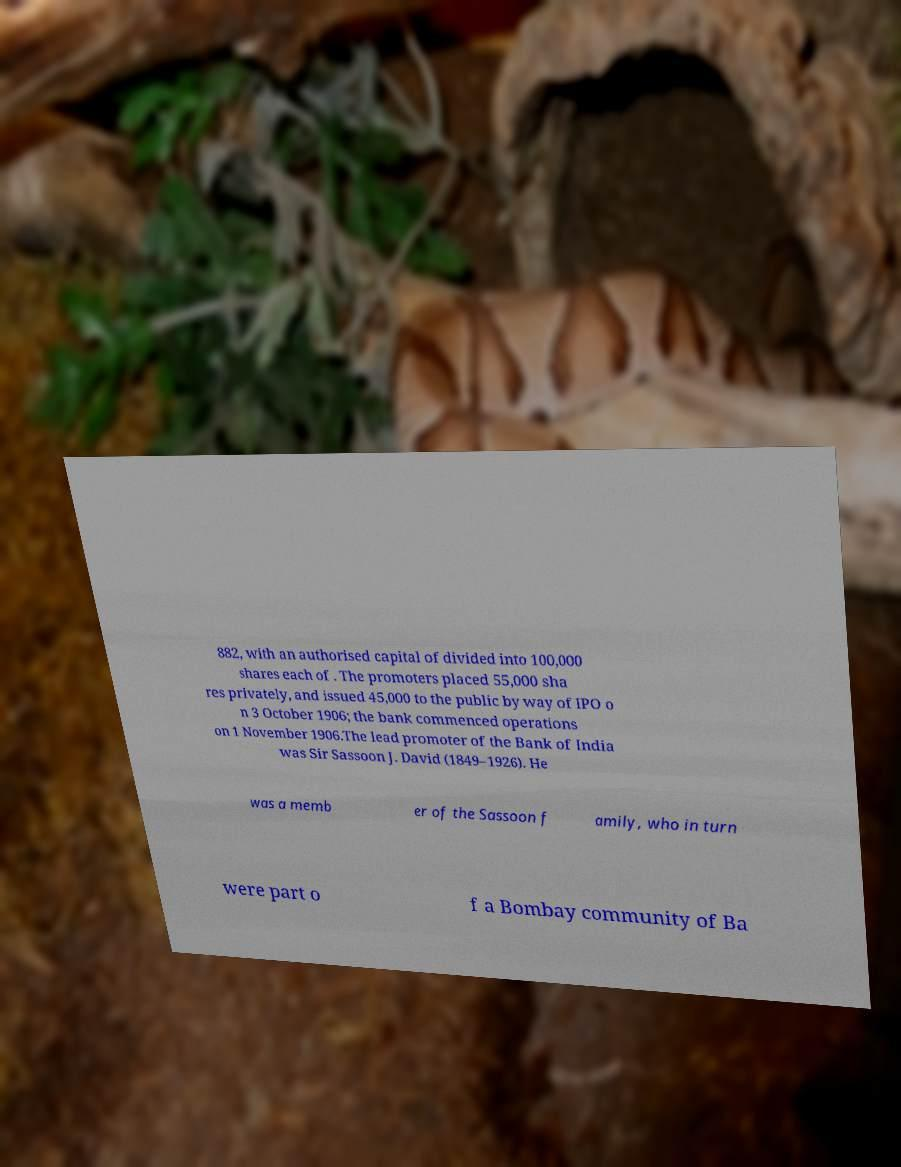Could you assist in decoding the text presented in this image and type it out clearly? 882, with an authorised capital of divided into 100,000 shares each of . The promoters placed 55,000 sha res privately, and issued 45,000 to the public by way of IPO o n 3 October 1906; the bank commenced operations on 1 November 1906.The lead promoter of the Bank of India was Sir Sassoon J. David (1849–1926). He was a memb er of the Sassoon f amily, who in turn were part o f a Bombay community of Ba 